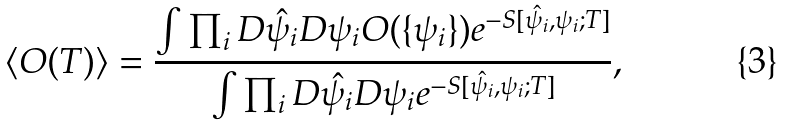<formula> <loc_0><loc_0><loc_500><loc_500>\left < O ( T ) \right > = \frac { \int \prod _ { i } D \hat { \psi } _ { i } D \psi _ { i } O ( \{ \psi _ { i } \} ) e ^ { - S [ \hat { \psi } _ { i } , \psi _ { i } ; T ] } } { \int \prod _ { i } D \hat { \psi } _ { i } D \psi _ { i } e ^ { - S [ \hat { \psi } _ { i } , \psi _ { i } ; T ] } } ,</formula> 